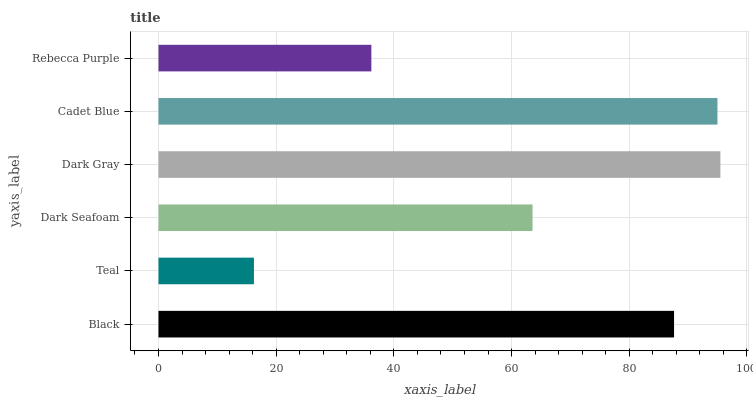Is Teal the minimum?
Answer yes or no. Yes. Is Dark Gray the maximum?
Answer yes or no. Yes. Is Dark Seafoam the minimum?
Answer yes or no. No. Is Dark Seafoam the maximum?
Answer yes or no. No. Is Dark Seafoam greater than Teal?
Answer yes or no. Yes. Is Teal less than Dark Seafoam?
Answer yes or no. Yes. Is Teal greater than Dark Seafoam?
Answer yes or no. No. Is Dark Seafoam less than Teal?
Answer yes or no. No. Is Black the high median?
Answer yes or no. Yes. Is Dark Seafoam the low median?
Answer yes or no. Yes. Is Rebecca Purple the high median?
Answer yes or no. No. Is Rebecca Purple the low median?
Answer yes or no. No. 